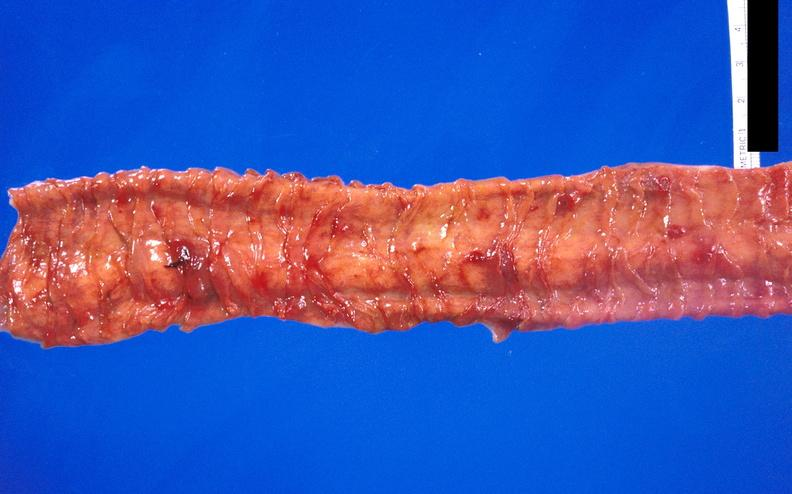what does this image show?
Answer the question using a single word or phrase. Hemorrhagic stress ulcers from patient with acute myelogenous leukemia 